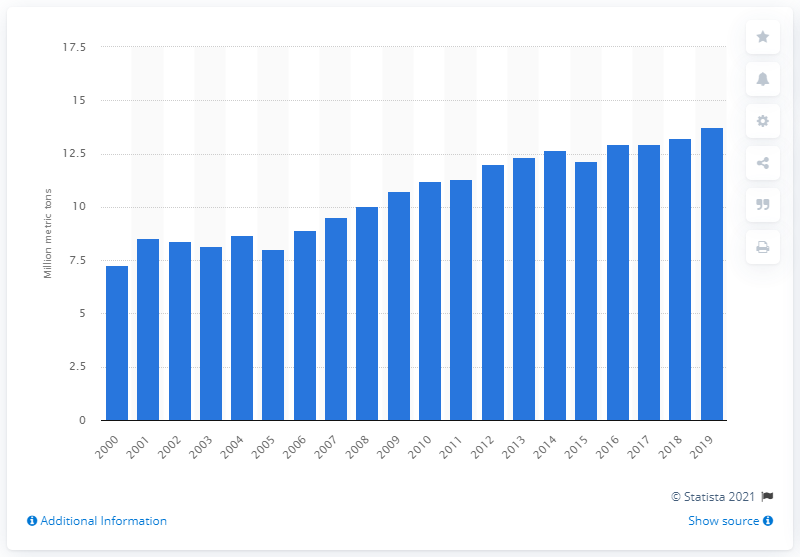Mention a couple of crucial points in this snapshot. In 2019, the global production of papayas was 13.74 million tons. In 2018, global papaya production was 13.24 million tons. 